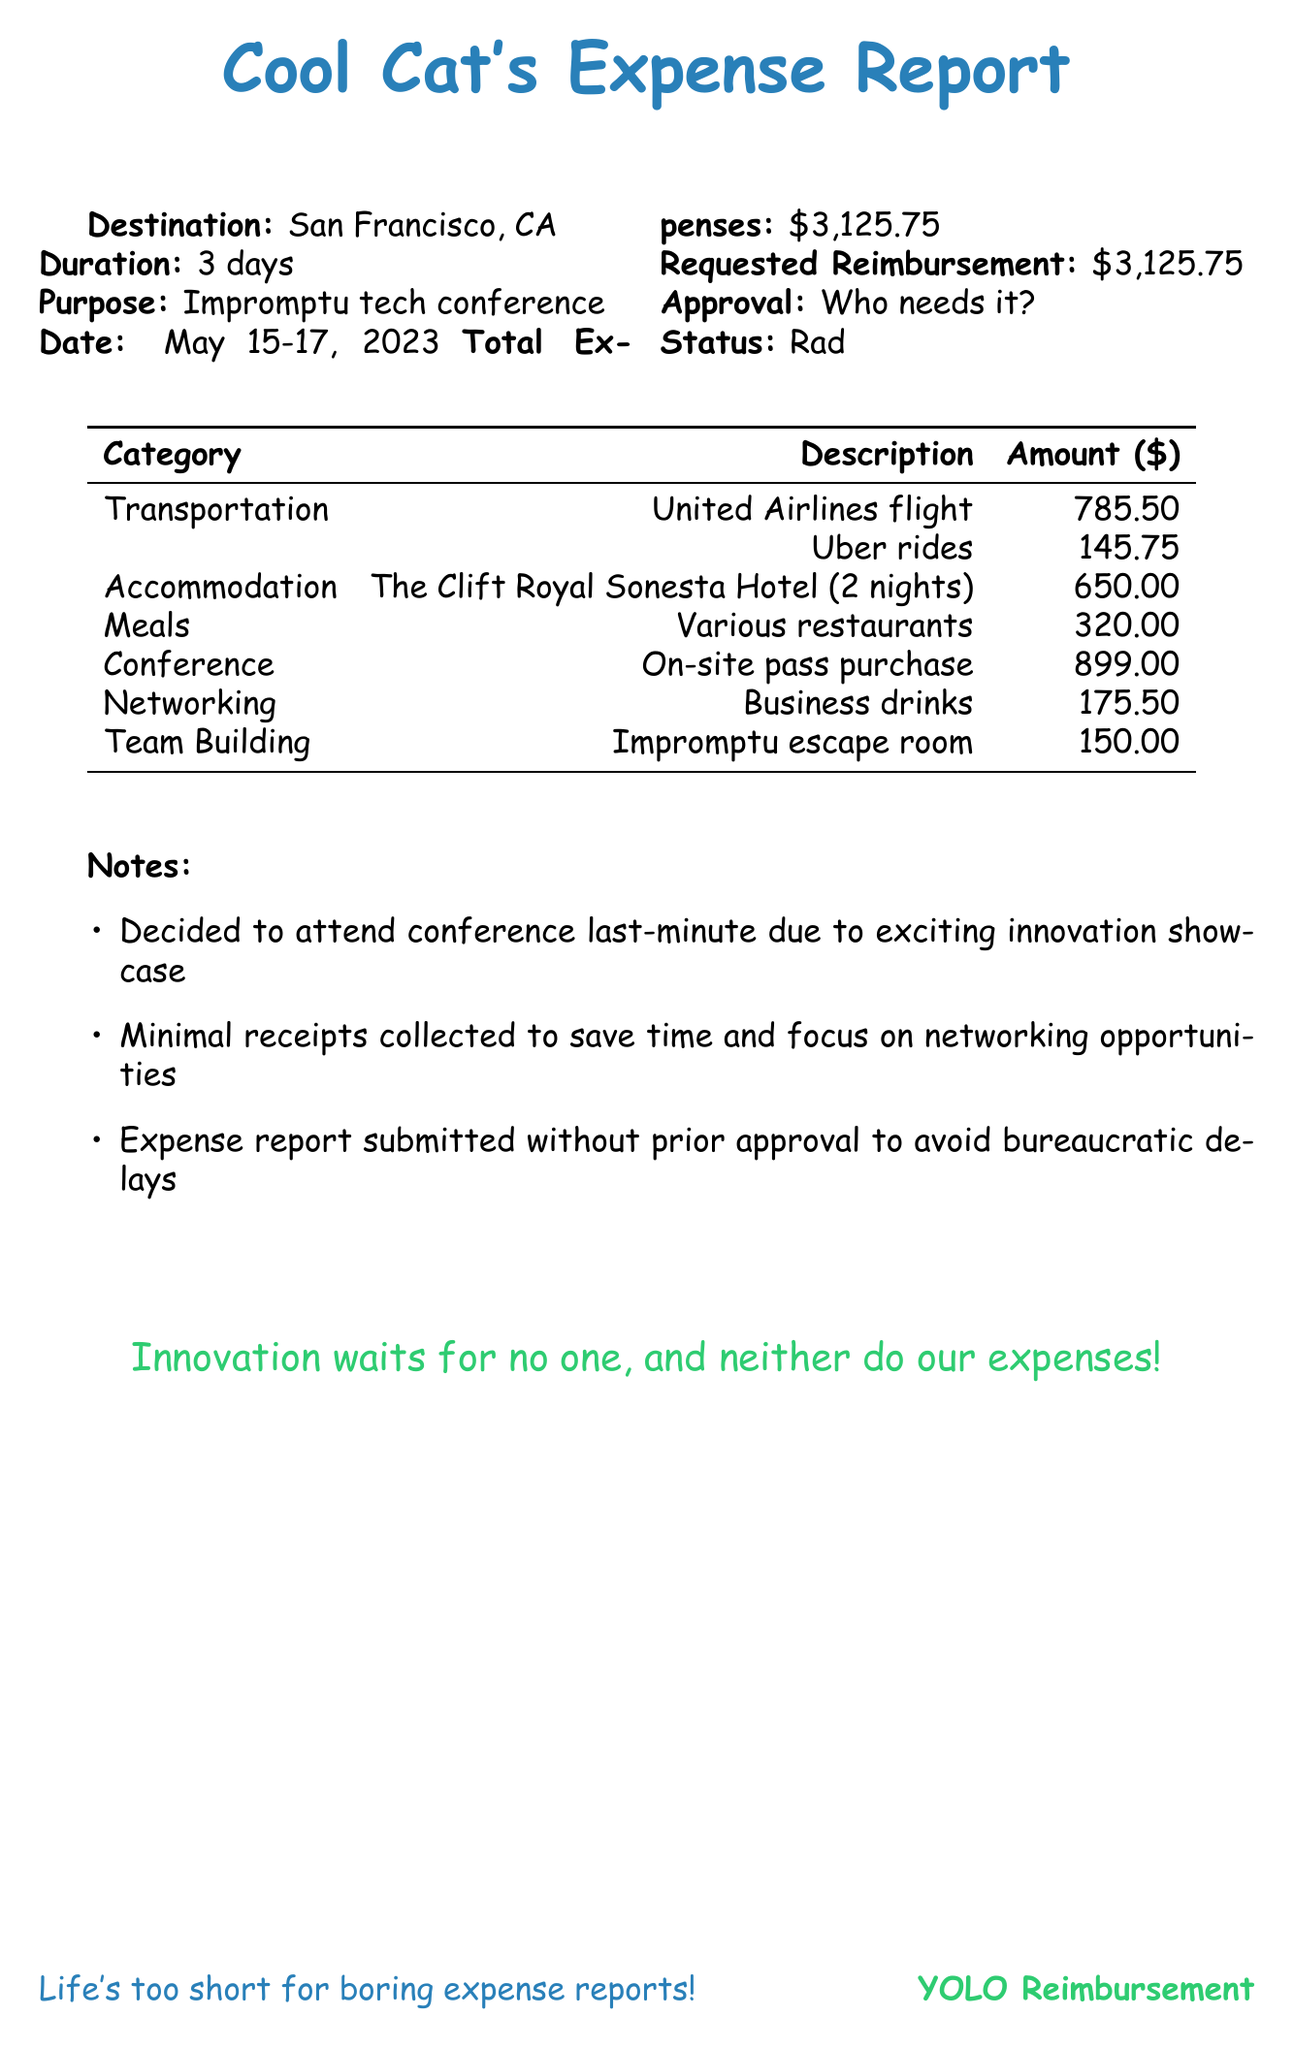What was the destination of the trip? The document specifies that the trip's destination was San Francisco, CA.
Answer: San Francisco, CA How many days did the trip last? The duration of the trip mentioned in the document is 3 days.
Answer: 3 days What was the total cost of accommodation? The document indicates that the total cost for the hotel accommodation was $650.00.
Answer: $650.00 What was the cost of the conference pass? The document lists the cost of the conference pass as $899.00, purchased on-site.
Answer: $899.00 Why were minimal receipts collected? The notes section states that minimal receipts were collected to save time and focus on networking opportunities.
Answer: To save time and focus on networking What was the total amount requested for reimbursement? The document mentions the total expenses and the amount requested for reimbursement, both of which are $3,125.75.
Answer: $3,125.75 How many nights was the accommodation booked for? The accommodation section clearly states that the hotel was booked for 2 nights.
Answer: 2 nights What transportation method was used for the flight? The transportation section specifies that United Airlines was used for the flight.
Answer: United Airlines What type of networking activity was included in the expenses? The miscellaneous section lists "business networking drinks" as part of the expenses.
Answer: Business networking drinks 